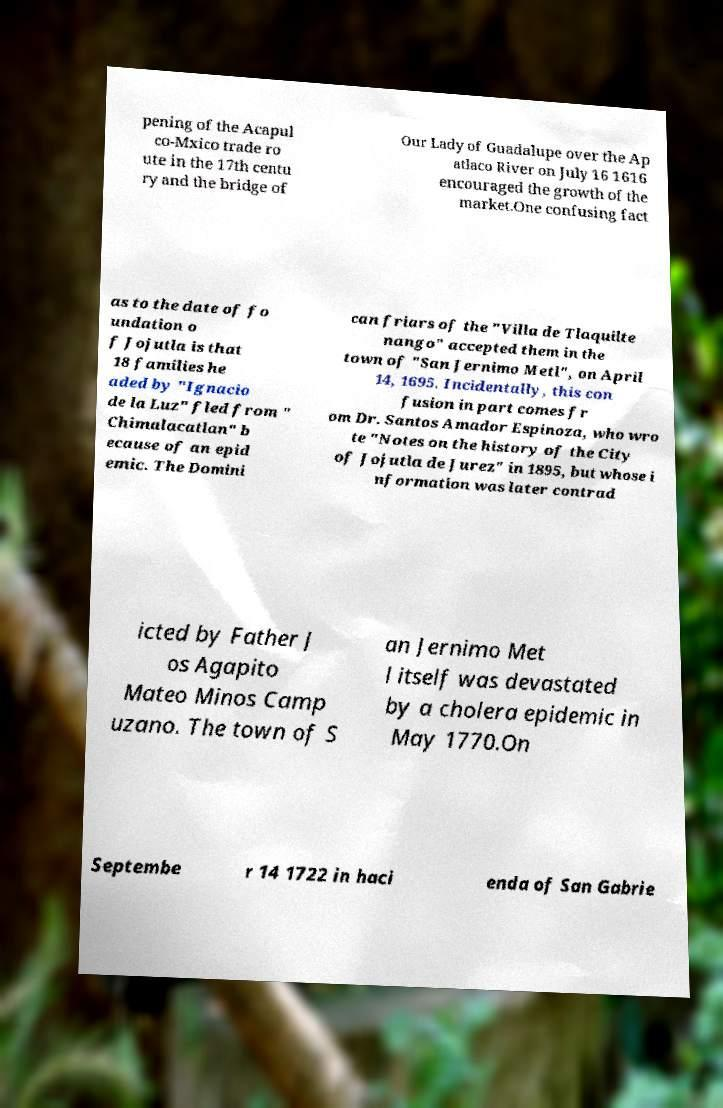What messages or text are displayed in this image? I need them in a readable, typed format. pening of the Acapul co-Mxico trade ro ute in the 17th centu ry and the bridge of Our Lady of Guadalupe over the Ap atlaco River on July 16 1616 encouraged the growth of the market.One confusing fact as to the date of fo undation o f Jojutla is that 18 families he aded by "Ignacio de la Luz" fled from " Chimalacatlan" b ecause of an epid emic. The Domini can friars of the "Villa de Tlaquilte nango" accepted them in the town of "San Jernimo Metl", on April 14, 1695. Incidentally, this con fusion in part comes fr om Dr. Santos Amador Espinoza, who wro te "Notes on the history of the City of Jojutla de Jurez" in 1895, but whose i nformation was later contrad icted by Father J os Agapito Mateo Minos Camp uzano. The town of S an Jernimo Met l itself was devastated by a cholera epidemic in May 1770.On Septembe r 14 1722 in haci enda of San Gabrie 